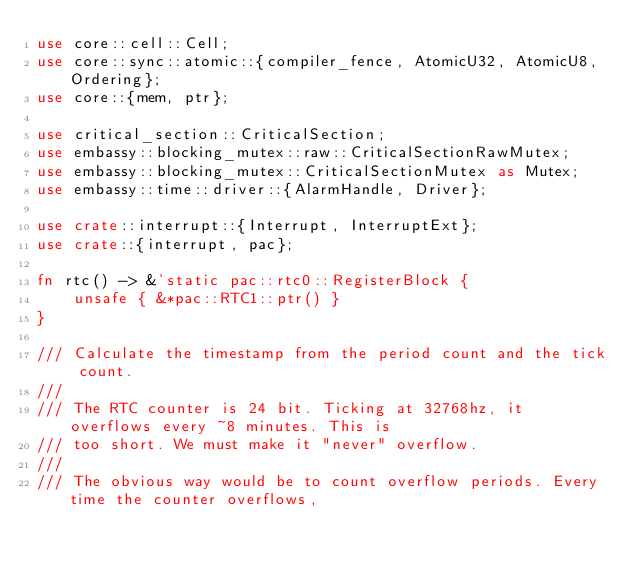Convert code to text. <code><loc_0><loc_0><loc_500><loc_500><_Rust_>use core::cell::Cell;
use core::sync::atomic::{compiler_fence, AtomicU32, AtomicU8, Ordering};
use core::{mem, ptr};

use critical_section::CriticalSection;
use embassy::blocking_mutex::raw::CriticalSectionRawMutex;
use embassy::blocking_mutex::CriticalSectionMutex as Mutex;
use embassy::time::driver::{AlarmHandle, Driver};

use crate::interrupt::{Interrupt, InterruptExt};
use crate::{interrupt, pac};

fn rtc() -> &'static pac::rtc0::RegisterBlock {
    unsafe { &*pac::RTC1::ptr() }
}

/// Calculate the timestamp from the period count and the tick count.
///
/// The RTC counter is 24 bit. Ticking at 32768hz, it overflows every ~8 minutes. This is
/// too short. We must make it "never" overflow.
///
/// The obvious way would be to count overflow periods. Every time the counter overflows,</code> 